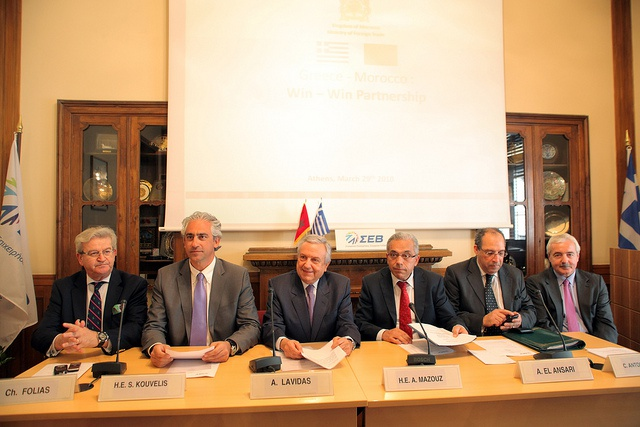Describe the objects in this image and their specific colors. I can see people in maroon, gray, black, and salmon tones, people in maroon, black, tan, and brown tones, people in maroon, black, salmon, and gray tones, people in maroon, black, salmon, brown, and tan tones, and people in maroon, black, gray, and salmon tones in this image. 